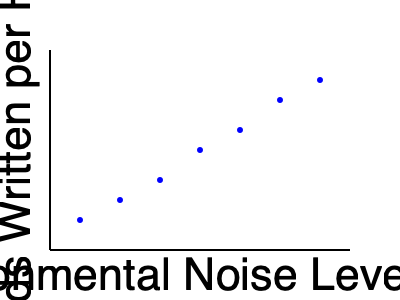As an author exploring the impact of environmental factors on writing productivity, you've collected data on the relationship between ambient noise levels and words written per hour. Based on the scatter plot, what type of correlation exists between environmental noise level and writing productivity, and how might this inform your choice of writing environment? To analyze the correlation between environmental noise level and writing productivity, we need to follow these steps:

1. Observe the overall trend in the scatter plot:
   The points seem to form a pattern moving from the upper left to the lower right of the graph.

2. Interpret the axes:
   - X-axis: Environmental Noise Level (dB)
   - Y-axis: Words Written per Hour

3. Analyze the relationship:
   As the noise level increases (moving right on the x-axis), the number of words written per hour decreases (moving down on the y-axis).

4. Determine the type of correlation:
   This pattern indicates a negative (or inverse) correlation between noise level and writing productivity.

5. Assess the strength of the correlation:
   The points form a fairly consistent downward trend, suggesting a strong negative correlation.

6. Consider the implications for writing environment:
   Given this strong negative correlation, it appears that lower noise levels are associated with higher writing productivity. This suggests that choosing a quieter writing environment might be beneficial for increasing word output.

7. Reflect on personal experience:
   As an author, you might consider how this data aligns with your own experiences and whether it could inform your choice of writing location or the use of noise-canceling tools.

8. Consider potential limitations:
   While the correlation is clear, it's important to remember that correlation does not imply causation. Other factors may be influencing this relationship.
Answer: Strong negative correlation; quiet environments may enhance writing productivity. 